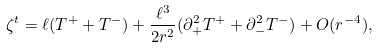<formula> <loc_0><loc_0><loc_500><loc_500>\zeta ^ { t } = \ell ( T ^ { + } + T ^ { - } ) + \frac { \ell ^ { 3 } } { 2 r ^ { 2 } } ( \partial _ { + } ^ { 2 } T ^ { + } + \partial _ { - } ^ { 2 } T ^ { - } ) + O ( r ^ { - 4 } ) ,</formula> 